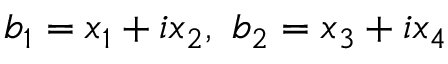Convert formula to latex. <formula><loc_0><loc_0><loc_500><loc_500>b _ { 1 } = x _ { 1 } + i x _ { 2 } , \ b _ { 2 } = x _ { 3 } + i x _ { 4 }</formula> 